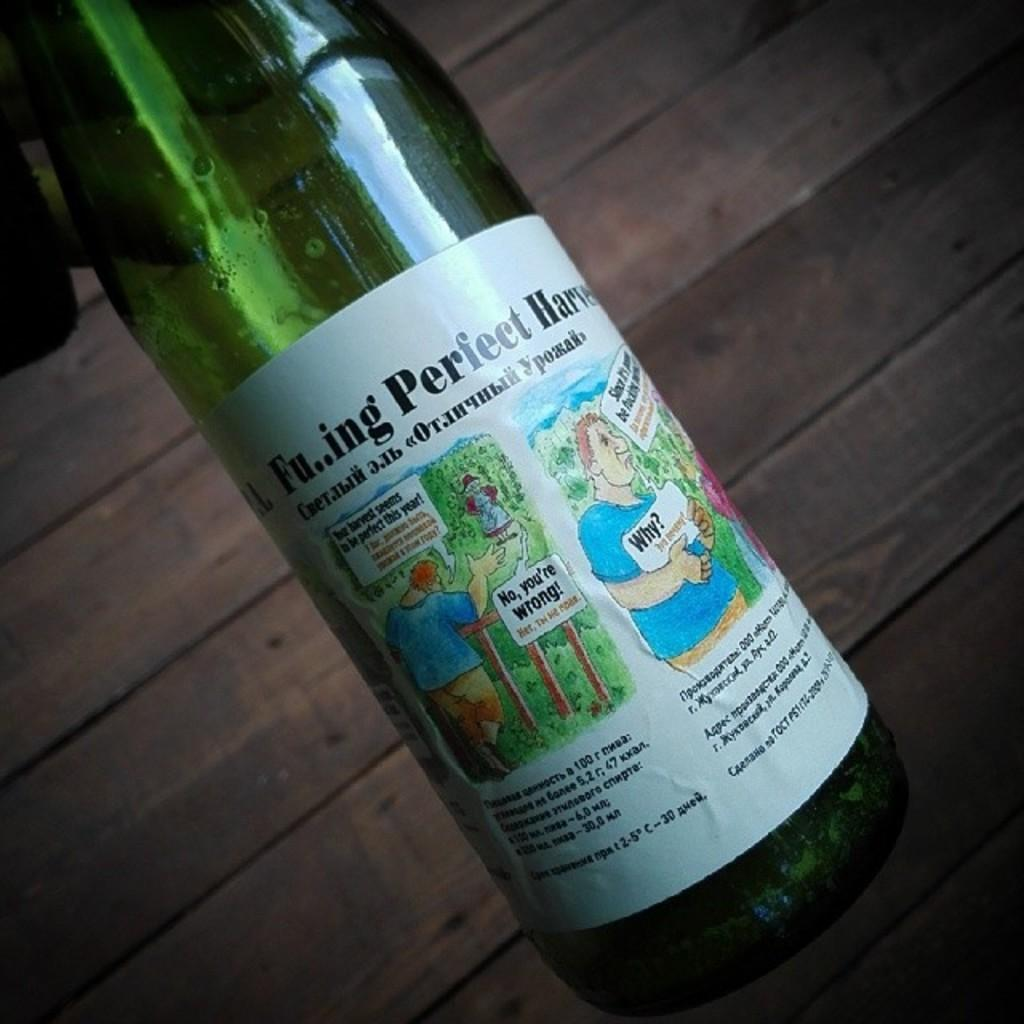<image>
Present a compact description of the photo's key features. A bottle of Fu...ing Perfect is held above a wooden floor. 